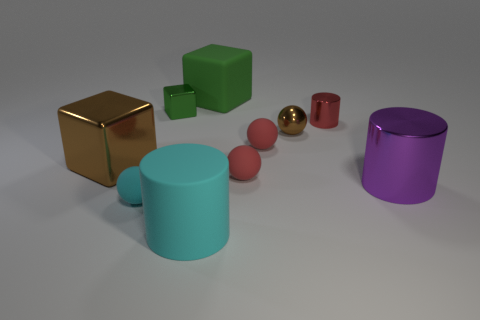Are there any objects in the image that could roll? Yes, there are several objects in the image that appear as if they could roll. The two sphere-like objects, one red and one gold, are round and would easily roll on a surface. The cylindrical objects, one purple and one turquoise, have circular bases and could also roll if tipped over.  What are the sizes of the rolling objects relative to each other? The gold sphere is the smallest rolling object in the image, whereas the red sphere is slightly larger. The two cylindrical objects are both larger than the spheres; the purple cylinder is taller and appears to have a greater diameter than the turquoise one, making it the largest of the rolling objects in relative size. 